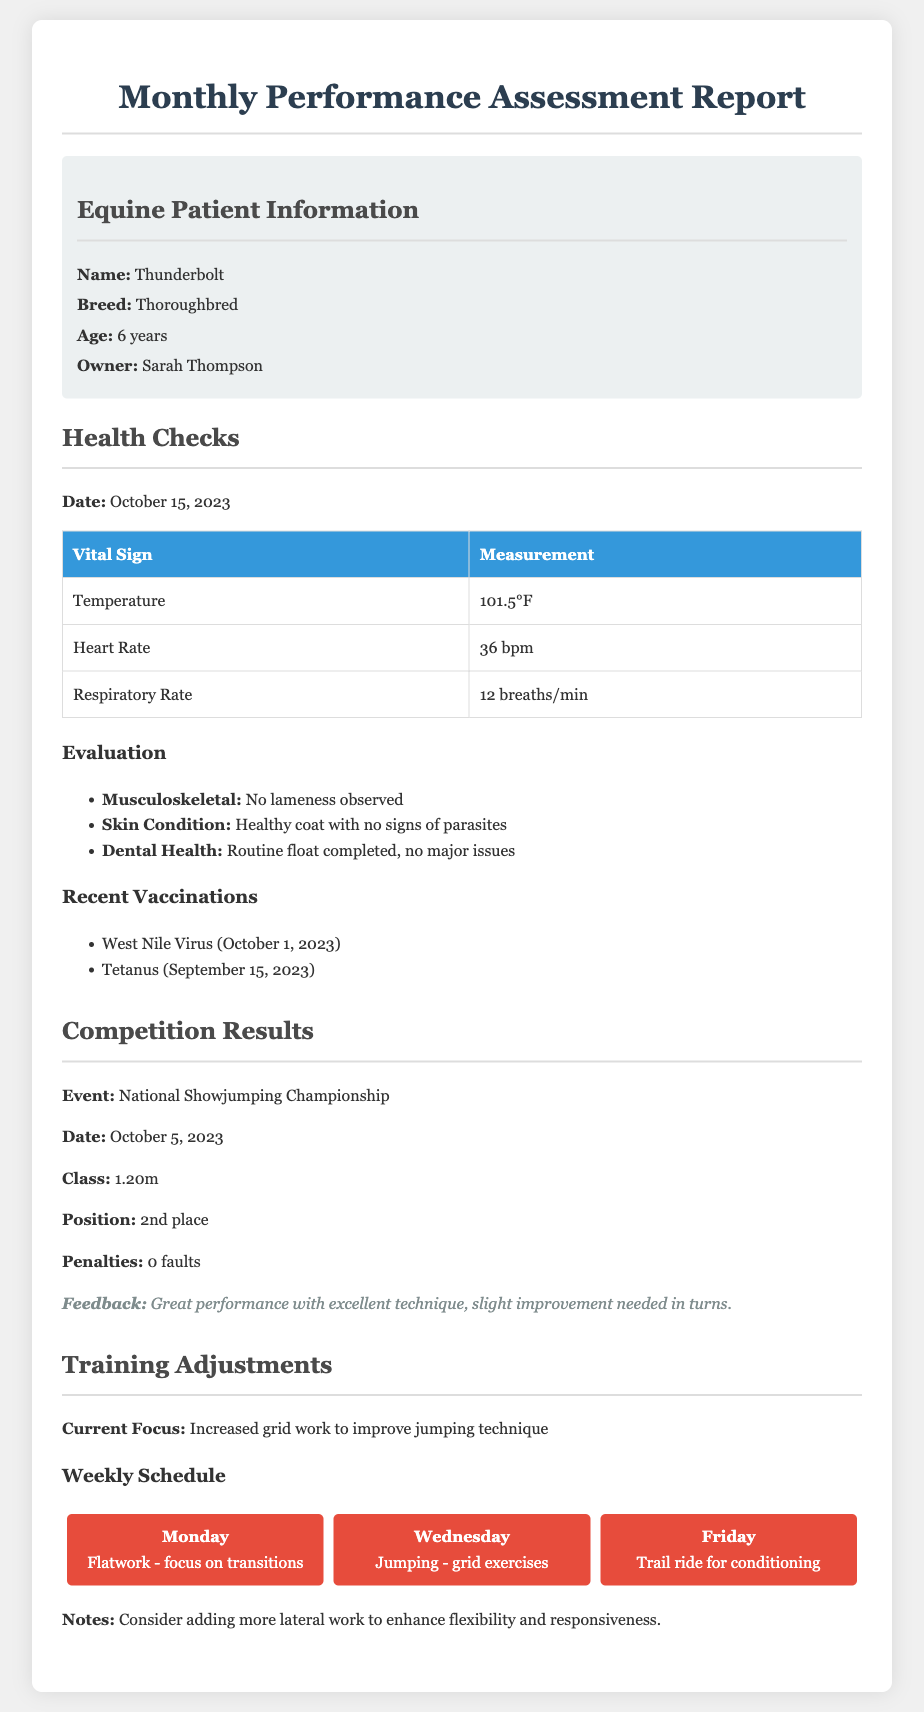What is the name of the horse? The horse's name is provided in the patient information section of the document.
Answer: Thunderbolt What is the breed of Thunderbolt? The breed information is given in the equine patient information section.
Answer: Thoroughbred What position did Thunderbolt achieve in the competition? The competition results section highlights Thunderbolt's performance in the event.
Answer: 2nd place When was Thunderbolt's last health check conducted? The date of the health check is mentioned in the health checks section of the document.
Answer: October 15, 2023 How many faults did Thunderbolt have in the National Showjumping Championship? The penalties for the competition are listed in the competition results.
Answer: 0 faults What is Thunderbolt's current training focus? The training adjustments section specifies the focus of the horse's training program.
Answer: Increased grid work to improve jumping technique What type of exercise is scheduled for Wednesday? The weekly schedule provides details about the training activities planned for each day.
Answer: Jumping - grid exercises What recent vaccine did Thunderbolt receive on October 1, 2023? The recent vaccinations section lists the vaccines administered to Thunderbolt.
Answer: West Nile Virus What additional training adjustment is suggested for Thunderbolt? The notes under training adjustments indicate recommendations for the horse's training.
Answer: More lateral work to enhance flexibility and responsiveness 